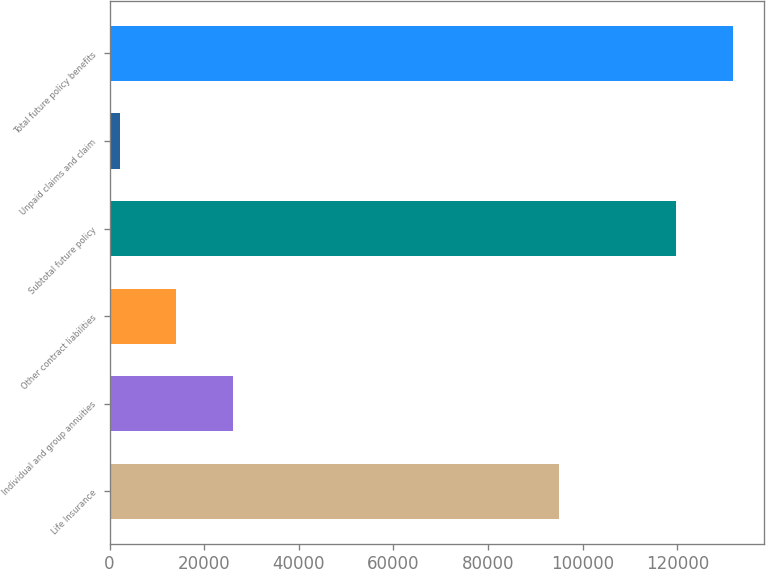<chart> <loc_0><loc_0><loc_500><loc_500><bar_chart><fcel>Life Insurance<fcel>Individual and group annuities<fcel>Other contract liabilities<fcel>Subtotal future policy<fcel>Unpaid claims and claim<fcel>Total future policy benefits<nl><fcel>94940<fcel>26115<fcel>14135.5<fcel>119795<fcel>2156<fcel>131774<nl></chart> 